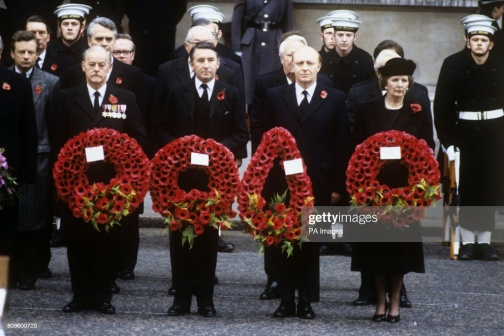What can you infer about the event from the clothing and expressions of the people in the image? The clothing and expressions of the people in the image suggest that this is a formal and solemn event, likely a memorial service or commemoration. The participants are dressed in formal black suits and coats, which is typical attire for such occasions, conveying respect and mourning. The presence of individuals in military uniforms indicates a possible military connection to the event, such as a commemoration of fallen soldiers. Their serious, somber expressions further emphasize the gravity of the moment, reflecting a collective sense of loss and remembrance. 